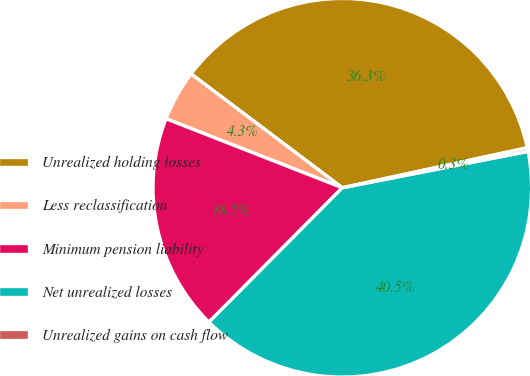Convert chart. <chart><loc_0><loc_0><loc_500><loc_500><pie_chart><fcel>Unrealized holding losses<fcel>Less reclassification<fcel>Minimum pension liability<fcel>Net unrealized losses<fcel>Unrealized gains on cash flow<nl><fcel>36.34%<fcel>4.33%<fcel>18.5%<fcel>40.52%<fcel>0.31%<nl></chart> 